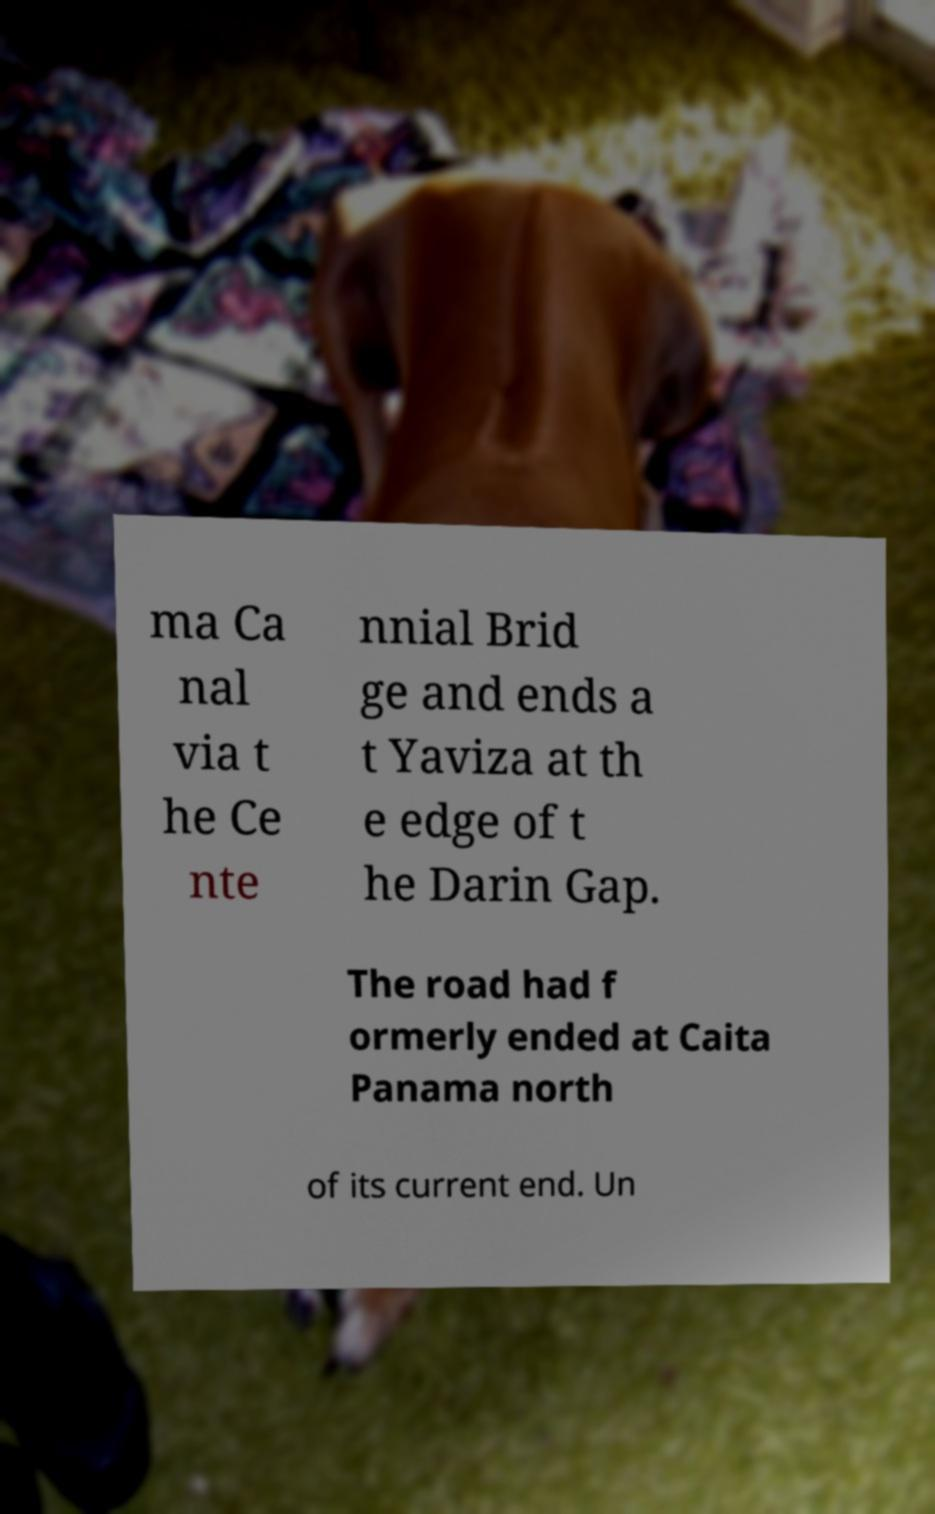Could you assist in decoding the text presented in this image and type it out clearly? ma Ca nal via t he Ce nte nnial Brid ge and ends a t Yaviza at th e edge of t he Darin Gap. The road had f ormerly ended at Caita Panama north of its current end. Un 